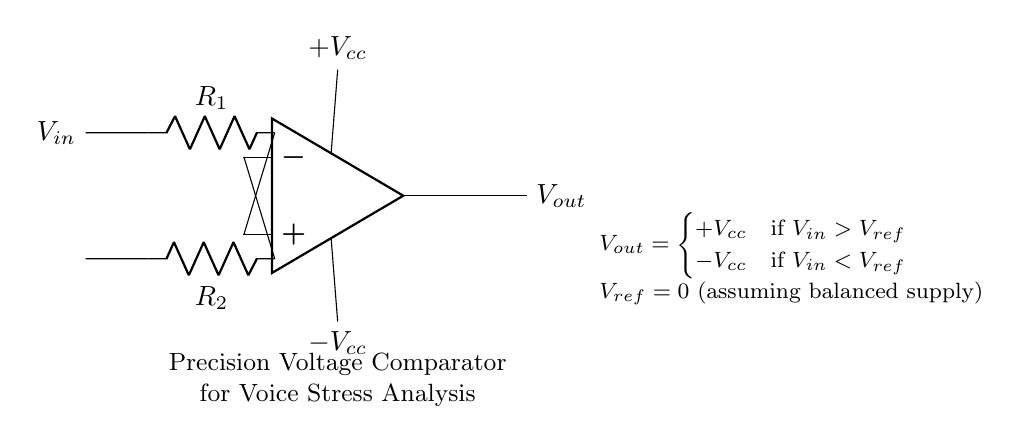What are the resistor values present in the circuit? The circuit diagram shows two resistors labeled R1 and R2. Their specific values are not provided, but they are essential components for the voltage comparator operation.
Answer: R1, R2 What is the role of the operational amplifier in this circuit? The operational amplifier is used to compare the input voltage (V_in) with a reference voltage (V_ref) and to provide an output signal (V_out) based on this comparison.
Answer: Comparator What is the output voltage when the input is greater than the reference voltage? According to the circuit's explanation, if V_in is greater than V_ref, the output voltage (V_out) will be equal to +V_cc.
Answer: +V_cc What happens to the output voltage when the input is less than the reference voltage? When V_in is less than V_ref, the output voltage (V_out) switches to -V_cc, indicating that the amplifier is in an opposite state.
Answer: -V_cc What is the reference voltage (V_ref) in this circuit? The circuit indicates that the reference voltage (V_ref) is set to zero, which suggests it is normally at ground potential for this condition.
Answer: 0 How does the circuit indicate a positive or negative output? The circuit is designed such that when V_in exceeds V_ref, V_out becomes positive (+V_cc), and when V_in is below V_ref, V_out turns negative (-V_cc), illustrating a binary response.
Answer: Binary response What kind of analysis is this circuit used for? The circuit is specifically mentioned as a precision voltage comparator used for voice stress analysis, emphasizing its application in detecting stress levels based on voice input.
Answer: Voice Stress Analysis 